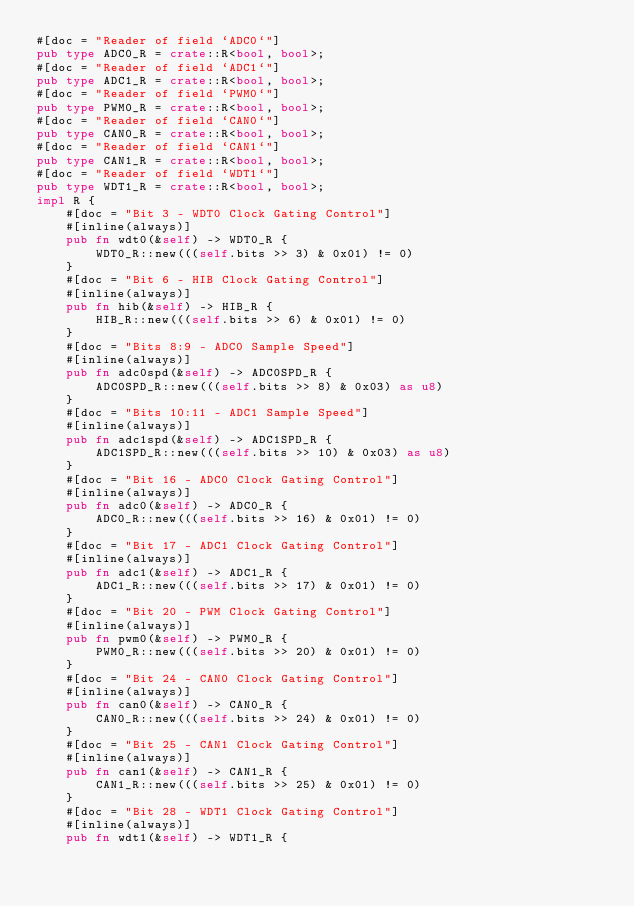Convert code to text. <code><loc_0><loc_0><loc_500><loc_500><_Rust_>#[doc = "Reader of field `ADC0`"]
pub type ADC0_R = crate::R<bool, bool>;
#[doc = "Reader of field `ADC1`"]
pub type ADC1_R = crate::R<bool, bool>;
#[doc = "Reader of field `PWM0`"]
pub type PWM0_R = crate::R<bool, bool>;
#[doc = "Reader of field `CAN0`"]
pub type CAN0_R = crate::R<bool, bool>;
#[doc = "Reader of field `CAN1`"]
pub type CAN1_R = crate::R<bool, bool>;
#[doc = "Reader of field `WDT1`"]
pub type WDT1_R = crate::R<bool, bool>;
impl R {
    #[doc = "Bit 3 - WDT0 Clock Gating Control"]
    #[inline(always)]
    pub fn wdt0(&self) -> WDT0_R {
        WDT0_R::new(((self.bits >> 3) & 0x01) != 0)
    }
    #[doc = "Bit 6 - HIB Clock Gating Control"]
    #[inline(always)]
    pub fn hib(&self) -> HIB_R {
        HIB_R::new(((self.bits >> 6) & 0x01) != 0)
    }
    #[doc = "Bits 8:9 - ADC0 Sample Speed"]
    #[inline(always)]
    pub fn adc0spd(&self) -> ADC0SPD_R {
        ADC0SPD_R::new(((self.bits >> 8) & 0x03) as u8)
    }
    #[doc = "Bits 10:11 - ADC1 Sample Speed"]
    #[inline(always)]
    pub fn adc1spd(&self) -> ADC1SPD_R {
        ADC1SPD_R::new(((self.bits >> 10) & 0x03) as u8)
    }
    #[doc = "Bit 16 - ADC0 Clock Gating Control"]
    #[inline(always)]
    pub fn adc0(&self) -> ADC0_R {
        ADC0_R::new(((self.bits >> 16) & 0x01) != 0)
    }
    #[doc = "Bit 17 - ADC1 Clock Gating Control"]
    #[inline(always)]
    pub fn adc1(&self) -> ADC1_R {
        ADC1_R::new(((self.bits >> 17) & 0x01) != 0)
    }
    #[doc = "Bit 20 - PWM Clock Gating Control"]
    #[inline(always)]
    pub fn pwm0(&self) -> PWM0_R {
        PWM0_R::new(((self.bits >> 20) & 0x01) != 0)
    }
    #[doc = "Bit 24 - CAN0 Clock Gating Control"]
    #[inline(always)]
    pub fn can0(&self) -> CAN0_R {
        CAN0_R::new(((self.bits >> 24) & 0x01) != 0)
    }
    #[doc = "Bit 25 - CAN1 Clock Gating Control"]
    #[inline(always)]
    pub fn can1(&self) -> CAN1_R {
        CAN1_R::new(((self.bits >> 25) & 0x01) != 0)
    }
    #[doc = "Bit 28 - WDT1 Clock Gating Control"]
    #[inline(always)]
    pub fn wdt1(&self) -> WDT1_R {</code> 